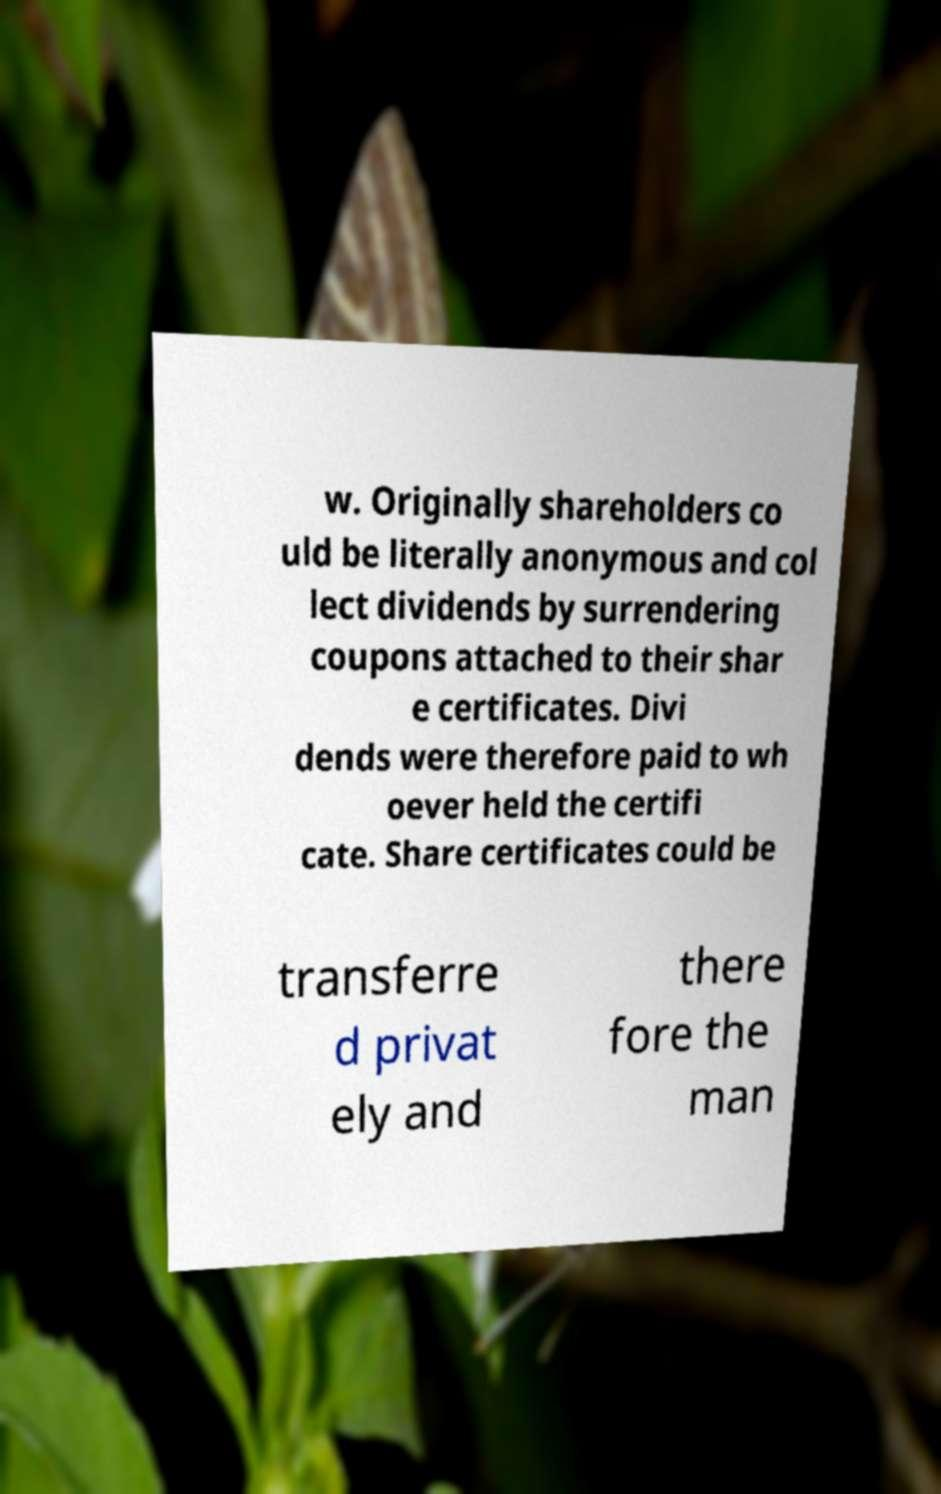Can you accurately transcribe the text from the provided image for me? w. Originally shareholders co uld be literally anonymous and col lect dividends by surrendering coupons attached to their shar e certificates. Divi dends were therefore paid to wh oever held the certifi cate. Share certificates could be transferre d privat ely and there fore the man 